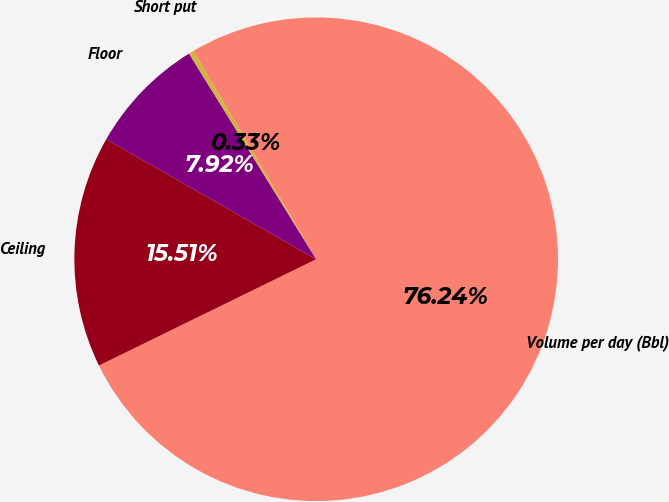Convert chart. <chart><loc_0><loc_0><loc_500><loc_500><pie_chart><fcel>Volume per day (Bbl)<fcel>Ceiling<fcel>Floor<fcel>Short put<nl><fcel>76.24%<fcel>15.51%<fcel>7.92%<fcel>0.33%<nl></chart> 